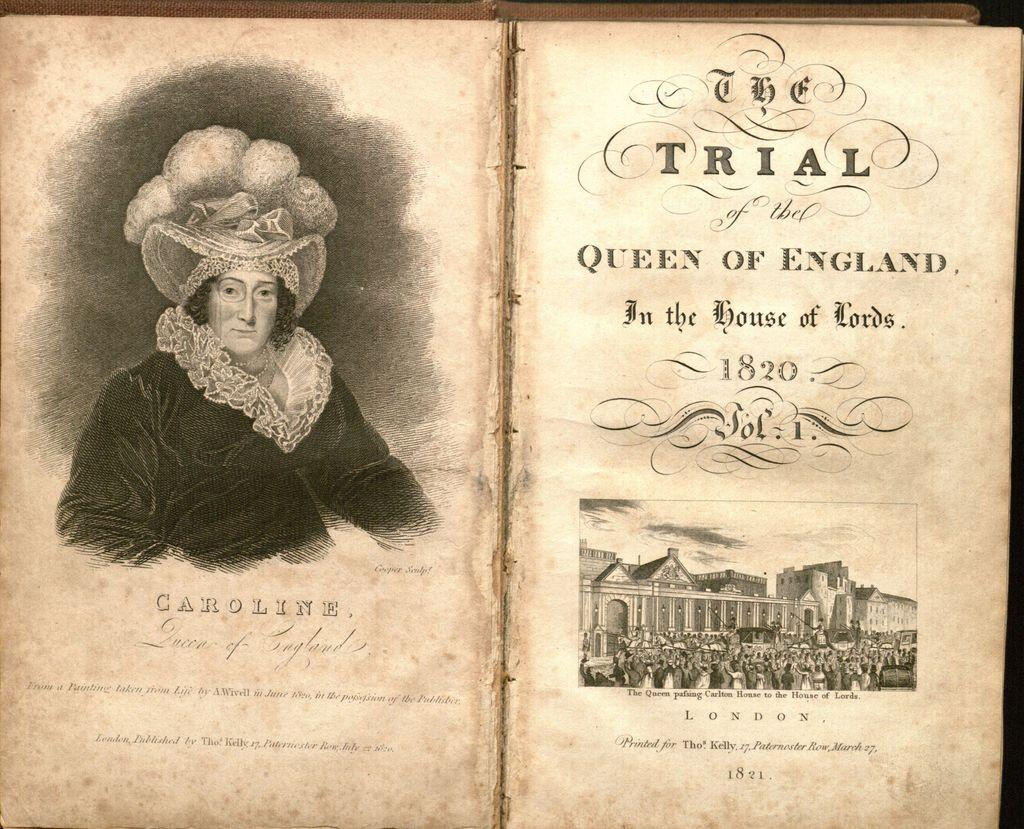<image>
Create a compact narrative representing the image presented. The trial of the Queen of England in the house of lords book. 